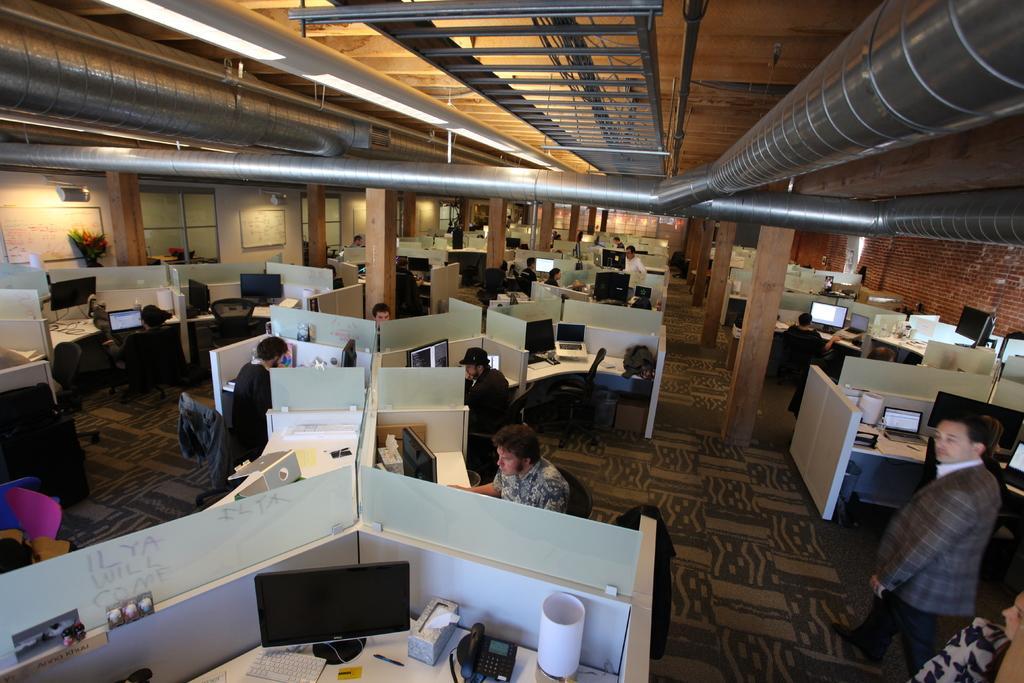In one or two sentences, can you explain what this image depicts? In this image I can see people and desks. I can also see computers on every desk. Here on ceiling I can see a pipeline 